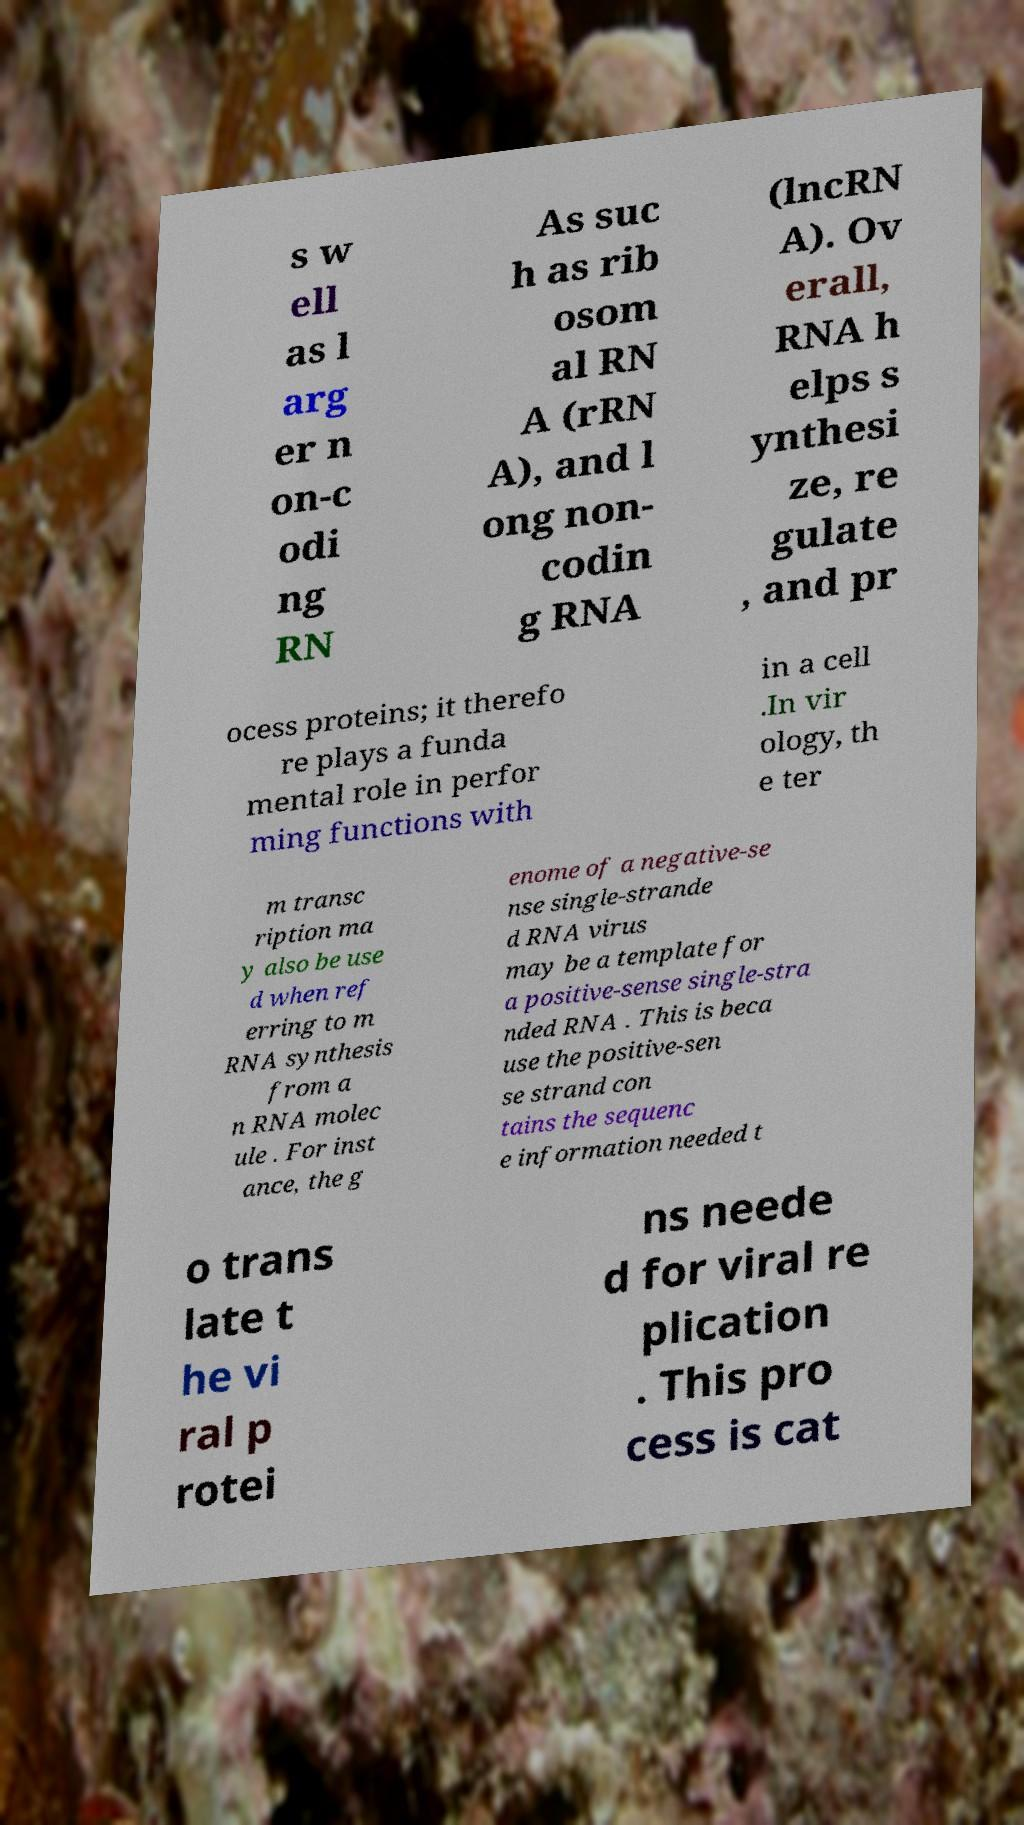Could you assist in decoding the text presented in this image and type it out clearly? s w ell as l arg er n on-c odi ng RN As suc h as rib osom al RN A (rRN A), and l ong non- codin g RNA (lncRN A). Ov erall, RNA h elps s ynthesi ze, re gulate , and pr ocess proteins; it therefo re plays a funda mental role in perfor ming functions with in a cell .In vir ology, th e ter m transc ription ma y also be use d when ref erring to m RNA synthesis from a n RNA molec ule . For inst ance, the g enome of a negative-se nse single-strande d RNA virus may be a template for a positive-sense single-stra nded RNA . This is beca use the positive-sen se strand con tains the sequenc e information needed t o trans late t he vi ral p rotei ns neede d for viral re plication . This pro cess is cat 